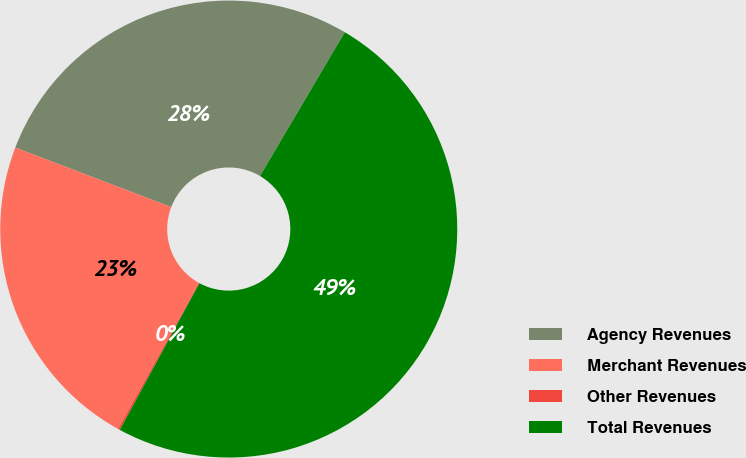Convert chart to OTSL. <chart><loc_0><loc_0><loc_500><loc_500><pie_chart><fcel>Agency Revenues<fcel>Merchant Revenues<fcel>Other Revenues<fcel>Total Revenues<nl><fcel>27.68%<fcel>22.75%<fcel>0.14%<fcel>49.44%<nl></chart> 